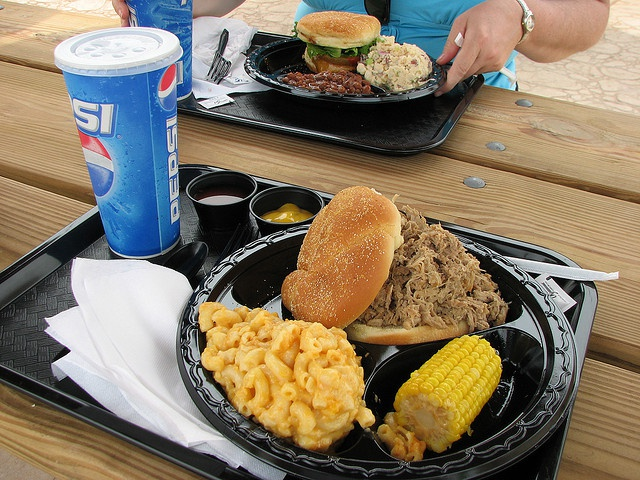Describe the objects in this image and their specific colors. I can see dining table in tan, gray, and maroon tones, sandwich in tan, red, and gray tones, cup in tan, blue, lightgray, and gray tones, people in tan, gray, and teal tones, and bowl in tan, black, gray, darkgray, and teal tones in this image. 